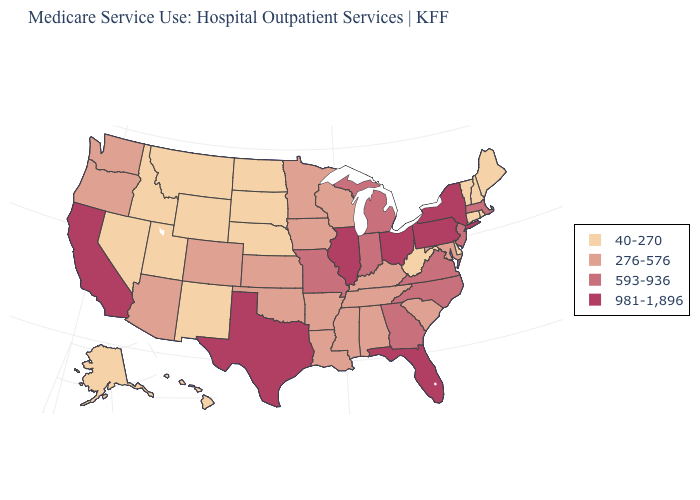How many symbols are there in the legend?
Concise answer only. 4. What is the value of Nevada?
Concise answer only. 40-270. Among the states that border New Jersey , which have the lowest value?
Be succinct. Delaware. Among the states that border Massachusetts , does Connecticut have the highest value?
Write a very short answer. No. Does Wyoming have the lowest value in the West?
Keep it brief. Yes. How many symbols are there in the legend?
Write a very short answer. 4. What is the value of Massachusetts?
Quick response, please. 593-936. What is the value of Maine?
Be succinct. 40-270. Among the states that border Minnesota , does North Dakota have the lowest value?
Answer briefly. Yes. What is the lowest value in the USA?
Keep it brief. 40-270. Does Florida have the same value as Kansas?
Write a very short answer. No. Name the states that have a value in the range 276-576?
Keep it brief. Alabama, Arizona, Arkansas, Colorado, Iowa, Kansas, Kentucky, Louisiana, Maryland, Minnesota, Mississippi, Oklahoma, Oregon, South Carolina, Tennessee, Washington, Wisconsin. Which states have the highest value in the USA?
Give a very brief answer. California, Florida, Illinois, New York, Ohio, Pennsylvania, Texas. Is the legend a continuous bar?
Short answer required. No. Name the states that have a value in the range 276-576?
Concise answer only. Alabama, Arizona, Arkansas, Colorado, Iowa, Kansas, Kentucky, Louisiana, Maryland, Minnesota, Mississippi, Oklahoma, Oregon, South Carolina, Tennessee, Washington, Wisconsin. 